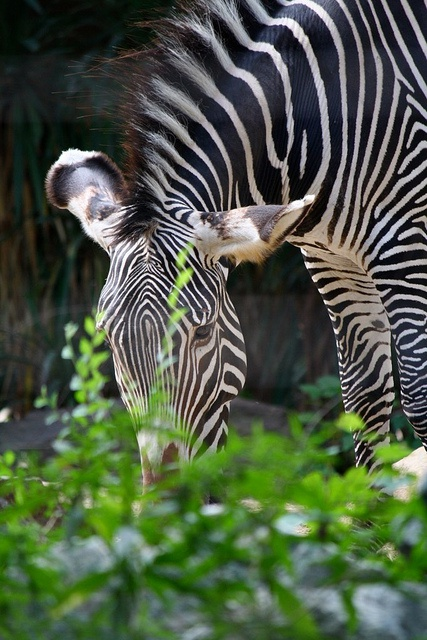Describe the objects in this image and their specific colors. I can see a zebra in black, darkgray, gray, and lightgray tones in this image. 